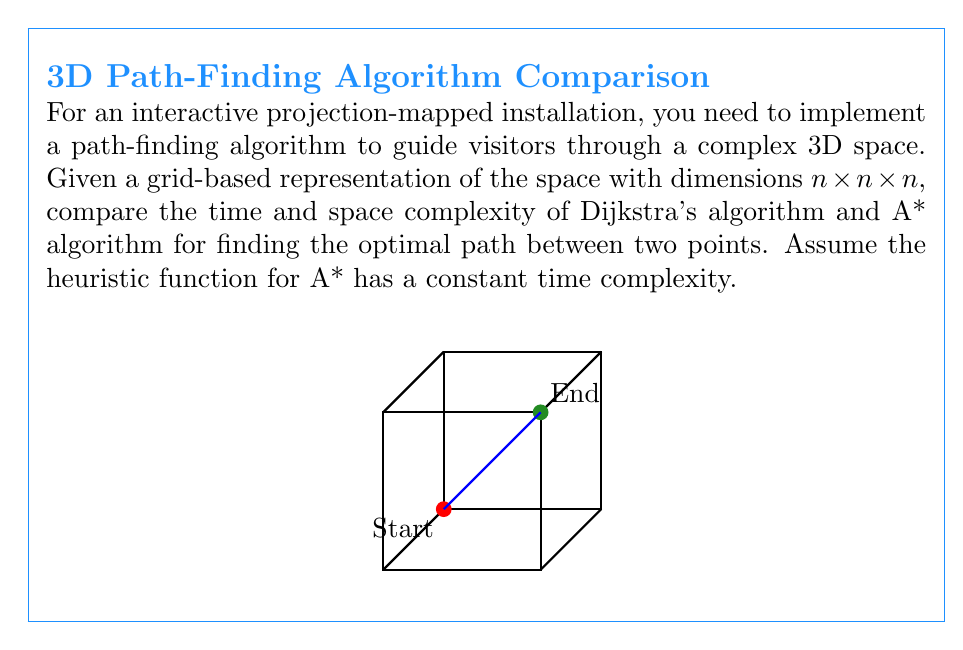Show me your answer to this math problem. To compare the time and space complexity of Dijkstra's algorithm and A* algorithm for this 3D path-finding problem, we need to analyze both algorithms:

1. Dijkstra's Algorithm:
   - Time Complexity: 
     * Uses a priority queue to select the next node to explore.
     * In the worst case, it explores all $n^3$ nodes.
     * Each node has up to 6 neighbors (in 3D space).
     * Time complexity: $O(n^3 \log n^3) = O(n^3 \log n)$
   - Space Complexity:
     * Stores distances for all nodes: $O(n^3)$
     * Priority queue can contain up to $n^3$ nodes: $O(n^3)$
     * Total space complexity: $O(n^3)$

2. A* Algorithm:
   - Time Complexity:
     * Similar to Dijkstra's, but uses a heuristic to guide the search.
     * In the worst case (poor heuristic), it degenerates to Dijkstra's.
     * Best case (perfect heuristic): $O(n)$ (direct path)
     * Average case: $O(n^3)$ (better than Dijkstra's)
   - Space Complexity:
     * Similar to Dijkstra's: $O(n^3)$

Comparison:
1. Time Complexity:
   - Dijkstra's: $O(n^3 \log n)$
   - A*: $O(n^3)$ (average case), $O(n^3 \log n)$ (worst case)
   
2. Space Complexity:
   - Both algorithms: $O(n^3)$

A* generally performs better in practice due to its heuristic guidance, which can significantly reduce the number of nodes explored. This is particularly beneficial for interactive installations where real-time performance is crucial.
Answer: Time: A* $O(n^3)$ avg, both $O(n^3 \log n)$ worst. Space: Both $O(n^3)$. A* typically faster. 